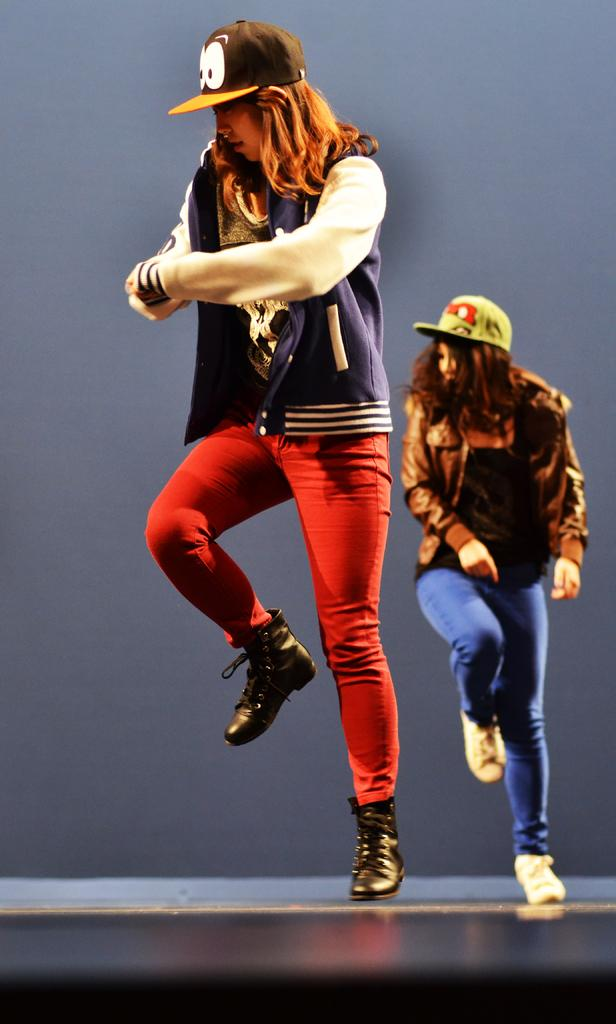What are the persons in the image doing? The persons in the image are performing in the center of the image. Where are the persons performing? The persons are performing on the floor. What can be seen in the background of the image? There is a wall in the background of the image. What type of notebook is visible in the hands of the crowd in the image? There is no crowd or notebook present in the image; it features persons performing on the floor. 